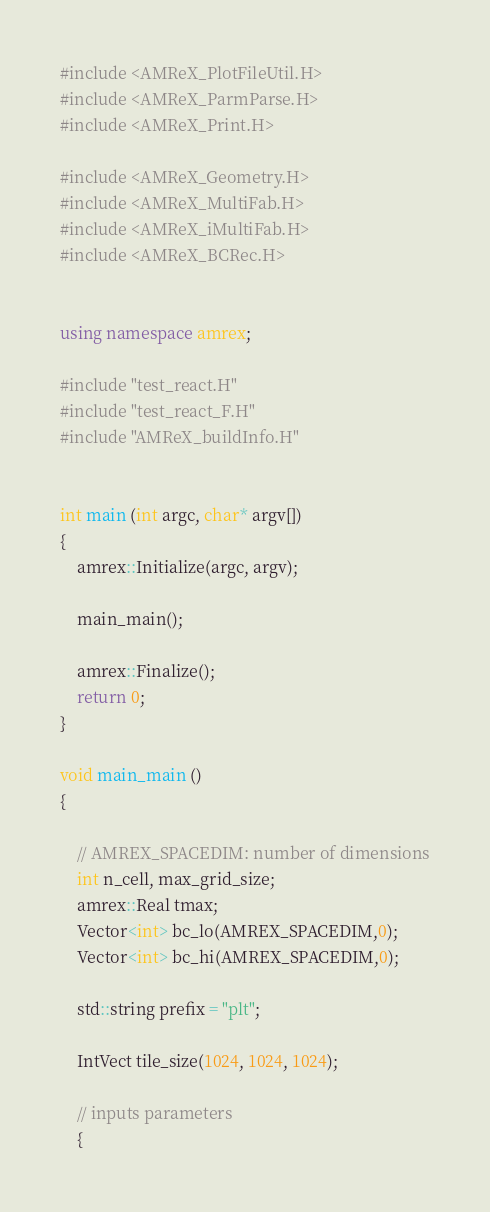Convert code to text. <code><loc_0><loc_0><loc_500><loc_500><_C++_>#include <AMReX_PlotFileUtil.H>
#include <AMReX_ParmParse.H>
#include <AMReX_Print.H>

#include <AMReX_Geometry.H>
#include <AMReX_MultiFab.H>
#include <AMReX_iMultiFab.H>
#include <AMReX_BCRec.H>


using namespace amrex;

#include "test_react.H"
#include "test_react_F.H"
#include "AMReX_buildInfo.H"


int main (int argc, char* argv[])
{
    amrex::Initialize(argc, argv);

    main_main();

    amrex::Finalize();
    return 0;
}

void main_main ()
{

    // AMREX_SPACEDIM: number of dimensions
    int n_cell, max_grid_size;
    amrex::Real tmax;
    Vector<int> bc_lo(AMREX_SPACEDIM,0);
    Vector<int> bc_hi(AMREX_SPACEDIM,0);

    std::string prefix = "plt";

    IntVect tile_size(1024, 1024, 1024);

    // inputs parameters
    {</code> 